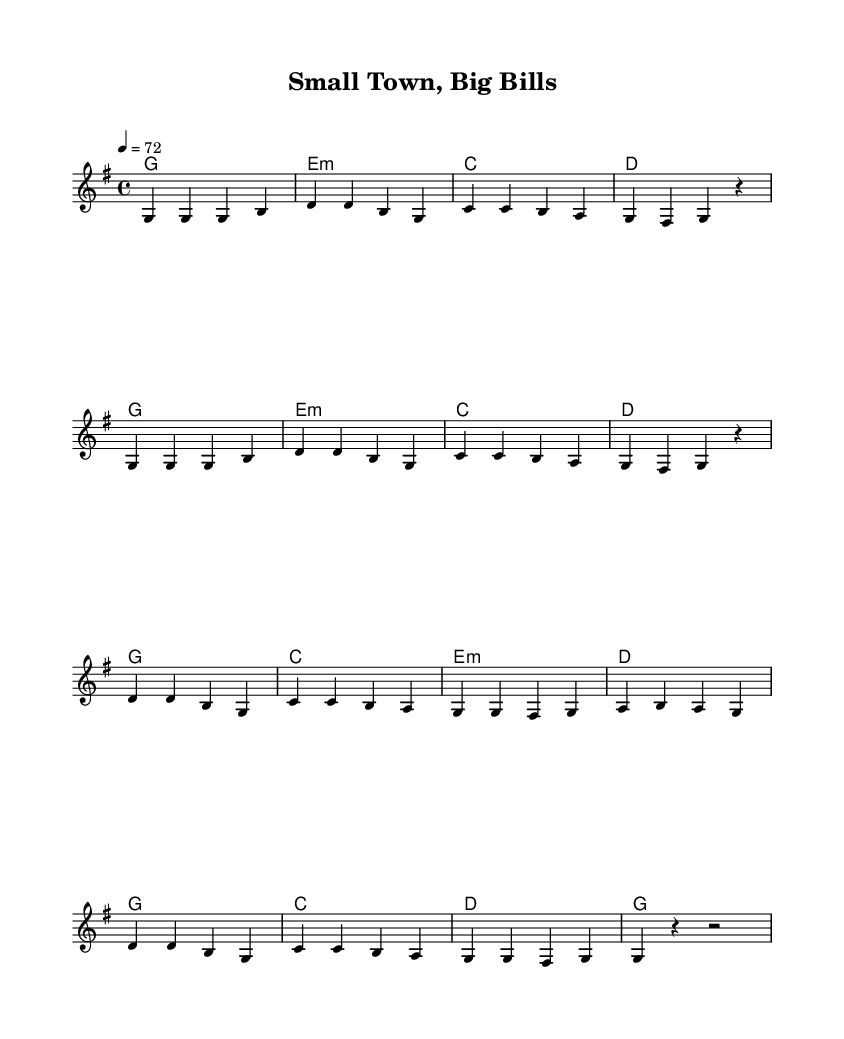What is the key signature of this music? The key signature is G major, which has one sharp (F#). This can be identified by looking at the key signature at the beginning of the staff.
Answer: G major What is the time signature of the piece? The time signature is 4/4, meaning there are 4 beats in each measure and the quarter note gets one beat. This is indicated at the beginning of the piece.
Answer: 4/4 What is the tempo marking for this music? The tempo is marked at 72 beats per minute, indicated in the score right after the time signature.
Answer: 72 How many measures are in the chorus? The chorus consists of 8 measures. Counting the measures within the chorus section reveals this total.
Answer: 8 What are the main themes expressed in the lyrics? The main themes include healthcare struggles and financial hardship in rural communities, as evidenced by the lyrics that discuss the lack of medical facilities and high healthcare costs.
Answer: Healthcare struggles What is the mood of the song based on the lyrics? The mood of the song is somber and reflective, as indicated by the lyrics that portray challenges and frustrations regarding healthcare accessibility in small towns.
Answer: Somber How do the harmonies support the melody in the chorus? The harmonies provide a foundation that supports the melody by aligning with the chord structure, enhancing emotional resonance, and maintaining the song's overall harmony.
Answer: Enhance emotional resonance 